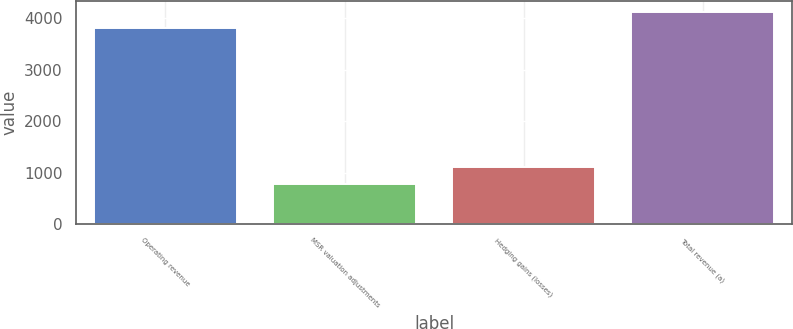Convert chart to OTSL. <chart><loc_0><loc_0><loc_500><loc_500><bar_chart><fcel>Operating revenue<fcel>MSR valuation adjustments<fcel>Hedging gains (losses)<fcel>Total revenue (a)<nl><fcel>3800<fcel>785<fcel>1109.5<fcel>4124.5<nl></chart> 